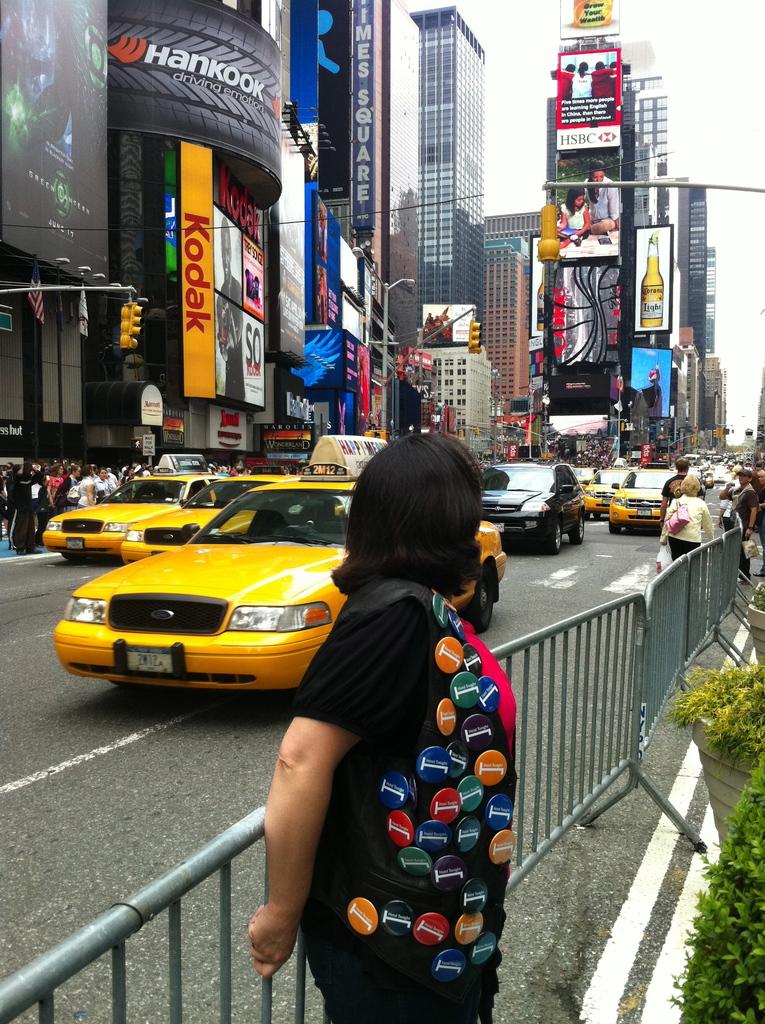Which camera company is featured on the orange banner?
Give a very brief answer. Kodak. 